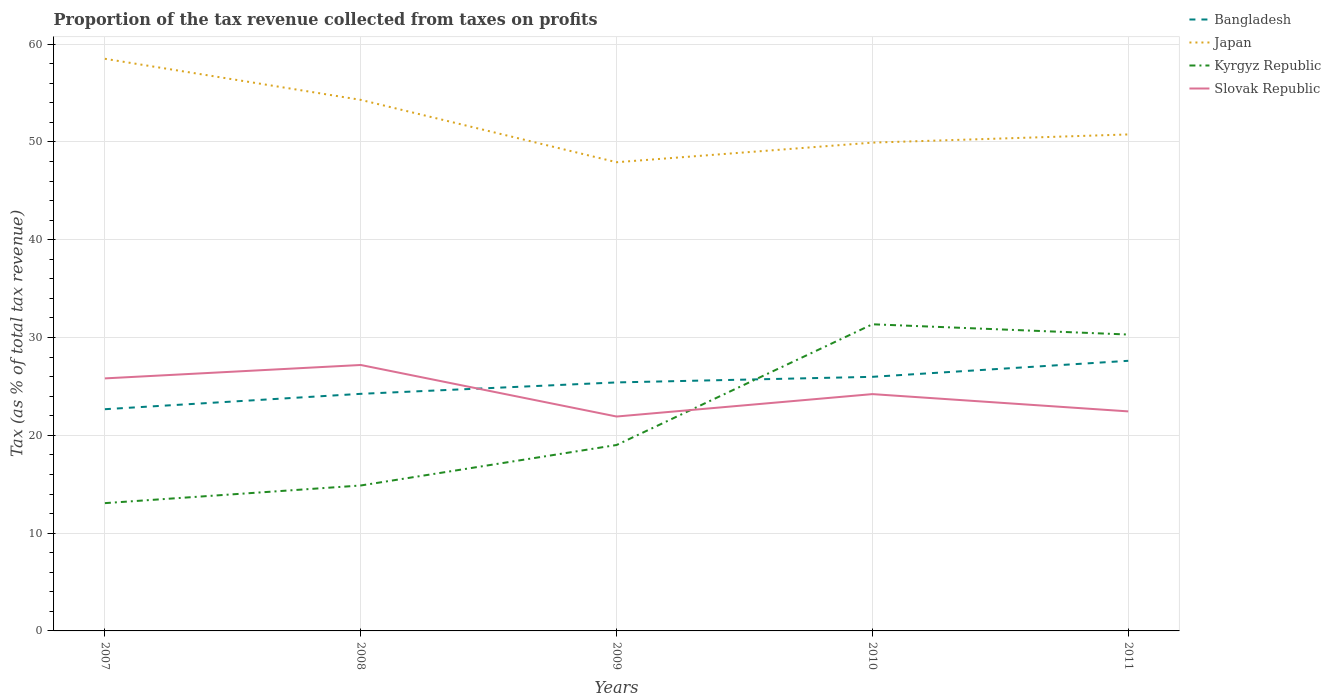Does the line corresponding to Kyrgyz Republic intersect with the line corresponding to Bangladesh?
Provide a short and direct response. Yes. Is the number of lines equal to the number of legend labels?
Give a very brief answer. Yes. Across all years, what is the maximum proportion of the tax revenue collected in Japan?
Your response must be concise. 47.92. What is the total proportion of the tax revenue collected in Slovak Republic in the graph?
Your response must be concise. 2.98. What is the difference between the highest and the second highest proportion of the tax revenue collected in Japan?
Keep it short and to the point. 10.58. What is the difference between the highest and the lowest proportion of the tax revenue collected in Kyrgyz Republic?
Give a very brief answer. 2. How many lines are there?
Your response must be concise. 4. What is the difference between two consecutive major ticks on the Y-axis?
Provide a short and direct response. 10. Does the graph contain any zero values?
Your answer should be very brief. No. How are the legend labels stacked?
Provide a short and direct response. Vertical. What is the title of the graph?
Give a very brief answer. Proportion of the tax revenue collected from taxes on profits. What is the label or title of the X-axis?
Your response must be concise. Years. What is the label or title of the Y-axis?
Ensure brevity in your answer.  Tax (as % of total tax revenue). What is the Tax (as % of total tax revenue) of Bangladesh in 2007?
Your answer should be compact. 22.67. What is the Tax (as % of total tax revenue) in Japan in 2007?
Your answer should be compact. 58.5. What is the Tax (as % of total tax revenue) in Kyrgyz Republic in 2007?
Offer a terse response. 13.07. What is the Tax (as % of total tax revenue) in Slovak Republic in 2007?
Your answer should be very brief. 25.82. What is the Tax (as % of total tax revenue) in Bangladesh in 2008?
Offer a very short reply. 24.24. What is the Tax (as % of total tax revenue) in Japan in 2008?
Your answer should be very brief. 54.3. What is the Tax (as % of total tax revenue) in Kyrgyz Republic in 2008?
Make the answer very short. 14.87. What is the Tax (as % of total tax revenue) of Slovak Republic in 2008?
Your answer should be compact. 27.19. What is the Tax (as % of total tax revenue) of Bangladesh in 2009?
Keep it short and to the point. 25.41. What is the Tax (as % of total tax revenue) of Japan in 2009?
Ensure brevity in your answer.  47.92. What is the Tax (as % of total tax revenue) of Kyrgyz Republic in 2009?
Offer a very short reply. 19.01. What is the Tax (as % of total tax revenue) in Slovak Republic in 2009?
Keep it short and to the point. 21.92. What is the Tax (as % of total tax revenue) in Bangladesh in 2010?
Make the answer very short. 25.98. What is the Tax (as % of total tax revenue) of Japan in 2010?
Provide a short and direct response. 49.93. What is the Tax (as % of total tax revenue) of Kyrgyz Republic in 2010?
Provide a short and direct response. 31.36. What is the Tax (as % of total tax revenue) in Slovak Republic in 2010?
Offer a terse response. 24.21. What is the Tax (as % of total tax revenue) in Bangladesh in 2011?
Provide a succinct answer. 27.62. What is the Tax (as % of total tax revenue) in Japan in 2011?
Provide a short and direct response. 50.77. What is the Tax (as % of total tax revenue) of Kyrgyz Republic in 2011?
Offer a terse response. 30.31. What is the Tax (as % of total tax revenue) in Slovak Republic in 2011?
Give a very brief answer. 22.45. Across all years, what is the maximum Tax (as % of total tax revenue) in Bangladesh?
Keep it short and to the point. 27.62. Across all years, what is the maximum Tax (as % of total tax revenue) in Japan?
Your answer should be compact. 58.5. Across all years, what is the maximum Tax (as % of total tax revenue) in Kyrgyz Republic?
Give a very brief answer. 31.36. Across all years, what is the maximum Tax (as % of total tax revenue) of Slovak Republic?
Make the answer very short. 27.19. Across all years, what is the minimum Tax (as % of total tax revenue) of Bangladesh?
Make the answer very short. 22.67. Across all years, what is the minimum Tax (as % of total tax revenue) of Japan?
Offer a terse response. 47.92. Across all years, what is the minimum Tax (as % of total tax revenue) in Kyrgyz Republic?
Your answer should be compact. 13.07. Across all years, what is the minimum Tax (as % of total tax revenue) of Slovak Republic?
Give a very brief answer. 21.92. What is the total Tax (as % of total tax revenue) in Bangladesh in the graph?
Provide a succinct answer. 125.92. What is the total Tax (as % of total tax revenue) in Japan in the graph?
Your response must be concise. 261.42. What is the total Tax (as % of total tax revenue) in Kyrgyz Republic in the graph?
Ensure brevity in your answer.  108.61. What is the total Tax (as % of total tax revenue) in Slovak Republic in the graph?
Offer a very short reply. 121.6. What is the difference between the Tax (as % of total tax revenue) of Bangladesh in 2007 and that in 2008?
Offer a terse response. -1.57. What is the difference between the Tax (as % of total tax revenue) of Japan in 2007 and that in 2008?
Offer a very short reply. 4.2. What is the difference between the Tax (as % of total tax revenue) in Kyrgyz Republic in 2007 and that in 2008?
Provide a short and direct response. -1.8. What is the difference between the Tax (as % of total tax revenue) in Slovak Republic in 2007 and that in 2008?
Your answer should be compact. -1.37. What is the difference between the Tax (as % of total tax revenue) in Bangladesh in 2007 and that in 2009?
Give a very brief answer. -2.74. What is the difference between the Tax (as % of total tax revenue) in Japan in 2007 and that in 2009?
Ensure brevity in your answer.  10.58. What is the difference between the Tax (as % of total tax revenue) in Kyrgyz Republic in 2007 and that in 2009?
Your answer should be very brief. -5.94. What is the difference between the Tax (as % of total tax revenue) in Slovak Republic in 2007 and that in 2009?
Your answer should be very brief. 3.9. What is the difference between the Tax (as % of total tax revenue) in Bangladesh in 2007 and that in 2010?
Your response must be concise. -3.31. What is the difference between the Tax (as % of total tax revenue) of Japan in 2007 and that in 2010?
Offer a very short reply. 8.57. What is the difference between the Tax (as % of total tax revenue) in Kyrgyz Republic in 2007 and that in 2010?
Your answer should be very brief. -18.29. What is the difference between the Tax (as % of total tax revenue) of Slovak Republic in 2007 and that in 2010?
Offer a very short reply. 1.61. What is the difference between the Tax (as % of total tax revenue) of Bangladesh in 2007 and that in 2011?
Provide a short and direct response. -4.95. What is the difference between the Tax (as % of total tax revenue) of Japan in 2007 and that in 2011?
Your answer should be very brief. 7.74. What is the difference between the Tax (as % of total tax revenue) of Kyrgyz Republic in 2007 and that in 2011?
Ensure brevity in your answer.  -17.24. What is the difference between the Tax (as % of total tax revenue) in Slovak Republic in 2007 and that in 2011?
Give a very brief answer. 3.37. What is the difference between the Tax (as % of total tax revenue) in Bangladesh in 2008 and that in 2009?
Provide a succinct answer. -1.17. What is the difference between the Tax (as % of total tax revenue) of Japan in 2008 and that in 2009?
Ensure brevity in your answer.  6.38. What is the difference between the Tax (as % of total tax revenue) of Kyrgyz Republic in 2008 and that in 2009?
Your answer should be very brief. -4.14. What is the difference between the Tax (as % of total tax revenue) in Slovak Republic in 2008 and that in 2009?
Ensure brevity in your answer.  5.27. What is the difference between the Tax (as % of total tax revenue) of Bangladesh in 2008 and that in 2010?
Provide a short and direct response. -1.74. What is the difference between the Tax (as % of total tax revenue) in Japan in 2008 and that in 2010?
Make the answer very short. 4.37. What is the difference between the Tax (as % of total tax revenue) in Kyrgyz Republic in 2008 and that in 2010?
Ensure brevity in your answer.  -16.48. What is the difference between the Tax (as % of total tax revenue) of Slovak Republic in 2008 and that in 2010?
Provide a short and direct response. 2.98. What is the difference between the Tax (as % of total tax revenue) of Bangladesh in 2008 and that in 2011?
Provide a succinct answer. -3.38. What is the difference between the Tax (as % of total tax revenue) of Japan in 2008 and that in 2011?
Offer a terse response. 3.54. What is the difference between the Tax (as % of total tax revenue) in Kyrgyz Republic in 2008 and that in 2011?
Offer a very short reply. -15.44. What is the difference between the Tax (as % of total tax revenue) of Slovak Republic in 2008 and that in 2011?
Keep it short and to the point. 4.74. What is the difference between the Tax (as % of total tax revenue) of Bangladesh in 2009 and that in 2010?
Your response must be concise. -0.57. What is the difference between the Tax (as % of total tax revenue) of Japan in 2009 and that in 2010?
Ensure brevity in your answer.  -2. What is the difference between the Tax (as % of total tax revenue) of Kyrgyz Republic in 2009 and that in 2010?
Your answer should be compact. -12.34. What is the difference between the Tax (as % of total tax revenue) of Slovak Republic in 2009 and that in 2010?
Your response must be concise. -2.29. What is the difference between the Tax (as % of total tax revenue) in Bangladesh in 2009 and that in 2011?
Offer a terse response. -2.21. What is the difference between the Tax (as % of total tax revenue) of Japan in 2009 and that in 2011?
Your answer should be compact. -2.84. What is the difference between the Tax (as % of total tax revenue) in Kyrgyz Republic in 2009 and that in 2011?
Your answer should be compact. -11.3. What is the difference between the Tax (as % of total tax revenue) of Slovak Republic in 2009 and that in 2011?
Your answer should be very brief. -0.53. What is the difference between the Tax (as % of total tax revenue) of Bangladesh in 2010 and that in 2011?
Keep it short and to the point. -1.64. What is the difference between the Tax (as % of total tax revenue) in Japan in 2010 and that in 2011?
Offer a very short reply. -0.84. What is the difference between the Tax (as % of total tax revenue) of Kyrgyz Republic in 2010 and that in 2011?
Give a very brief answer. 1.05. What is the difference between the Tax (as % of total tax revenue) of Slovak Republic in 2010 and that in 2011?
Your response must be concise. 1.77. What is the difference between the Tax (as % of total tax revenue) of Bangladesh in 2007 and the Tax (as % of total tax revenue) of Japan in 2008?
Your answer should be very brief. -31.63. What is the difference between the Tax (as % of total tax revenue) in Bangladesh in 2007 and the Tax (as % of total tax revenue) in Kyrgyz Republic in 2008?
Offer a very short reply. 7.8. What is the difference between the Tax (as % of total tax revenue) in Bangladesh in 2007 and the Tax (as % of total tax revenue) in Slovak Republic in 2008?
Ensure brevity in your answer.  -4.52. What is the difference between the Tax (as % of total tax revenue) in Japan in 2007 and the Tax (as % of total tax revenue) in Kyrgyz Republic in 2008?
Offer a very short reply. 43.63. What is the difference between the Tax (as % of total tax revenue) in Japan in 2007 and the Tax (as % of total tax revenue) in Slovak Republic in 2008?
Offer a very short reply. 31.31. What is the difference between the Tax (as % of total tax revenue) in Kyrgyz Republic in 2007 and the Tax (as % of total tax revenue) in Slovak Republic in 2008?
Your answer should be very brief. -14.13. What is the difference between the Tax (as % of total tax revenue) in Bangladesh in 2007 and the Tax (as % of total tax revenue) in Japan in 2009?
Your answer should be compact. -25.25. What is the difference between the Tax (as % of total tax revenue) in Bangladesh in 2007 and the Tax (as % of total tax revenue) in Kyrgyz Republic in 2009?
Your answer should be very brief. 3.66. What is the difference between the Tax (as % of total tax revenue) of Bangladesh in 2007 and the Tax (as % of total tax revenue) of Slovak Republic in 2009?
Your answer should be compact. 0.75. What is the difference between the Tax (as % of total tax revenue) in Japan in 2007 and the Tax (as % of total tax revenue) in Kyrgyz Republic in 2009?
Give a very brief answer. 39.49. What is the difference between the Tax (as % of total tax revenue) in Japan in 2007 and the Tax (as % of total tax revenue) in Slovak Republic in 2009?
Make the answer very short. 36.58. What is the difference between the Tax (as % of total tax revenue) in Kyrgyz Republic in 2007 and the Tax (as % of total tax revenue) in Slovak Republic in 2009?
Offer a very short reply. -8.86. What is the difference between the Tax (as % of total tax revenue) of Bangladesh in 2007 and the Tax (as % of total tax revenue) of Japan in 2010?
Offer a terse response. -27.26. What is the difference between the Tax (as % of total tax revenue) of Bangladesh in 2007 and the Tax (as % of total tax revenue) of Kyrgyz Republic in 2010?
Offer a terse response. -8.68. What is the difference between the Tax (as % of total tax revenue) in Bangladesh in 2007 and the Tax (as % of total tax revenue) in Slovak Republic in 2010?
Give a very brief answer. -1.54. What is the difference between the Tax (as % of total tax revenue) in Japan in 2007 and the Tax (as % of total tax revenue) in Kyrgyz Republic in 2010?
Ensure brevity in your answer.  27.15. What is the difference between the Tax (as % of total tax revenue) of Japan in 2007 and the Tax (as % of total tax revenue) of Slovak Republic in 2010?
Keep it short and to the point. 34.29. What is the difference between the Tax (as % of total tax revenue) in Kyrgyz Republic in 2007 and the Tax (as % of total tax revenue) in Slovak Republic in 2010?
Keep it short and to the point. -11.15. What is the difference between the Tax (as % of total tax revenue) of Bangladesh in 2007 and the Tax (as % of total tax revenue) of Japan in 2011?
Provide a short and direct response. -28.1. What is the difference between the Tax (as % of total tax revenue) in Bangladesh in 2007 and the Tax (as % of total tax revenue) in Kyrgyz Republic in 2011?
Give a very brief answer. -7.64. What is the difference between the Tax (as % of total tax revenue) of Bangladesh in 2007 and the Tax (as % of total tax revenue) of Slovak Republic in 2011?
Provide a succinct answer. 0.22. What is the difference between the Tax (as % of total tax revenue) of Japan in 2007 and the Tax (as % of total tax revenue) of Kyrgyz Republic in 2011?
Give a very brief answer. 28.2. What is the difference between the Tax (as % of total tax revenue) of Japan in 2007 and the Tax (as % of total tax revenue) of Slovak Republic in 2011?
Provide a short and direct response. 36.05. What is the difference between the Tax (as % of total tax revenue) in Kyrgyz Republic in 2007 and the Tax (as % of total tax revenue) in Slovak Republic in 2011?
Keep it short and to the point. -9.38. What is the difference between the Tax (as % of total tax revenue) of Bangladesh in 2008 and the Tax (as % of total tax revenue) of Japan in 2009?
Provide a succinct answer. -23.68. What is the difference between the Tax (as % of total tax revenue) of Bangladesh in 2008 and the Tax (as % of total tax revenue) of Kyrgyz Republic in 2009?
Offer a very short reply. 5.23. What is the difference between the Tax (as % of total tax revenue) of Bangladesh in 2008 and the Tax (as % of total tax revenue) of Slovak Republic in 2009?
Keep it short and to the point. 2.32. What is the difference between the Tax (as % of total tax revenue) of Japan in 2008 and the Tax (as % of total tax revenue) of Kyrgyz Republic in 2009?
Your response must be concise. 35.29. What is the difference between the Tax (as % of total tax revenue) of Japan in 2008 and the Tax (as % of total tax revenue) of Slovak Republic in 2009?
Offer a very short reply. 32.38. What is the difference between the Tax (as % of total tax revenue) in Kyrgyz Republic in 2008 and the Tax (as % of total tax revenue) in Slovak Republic in 2009?
Your answer should be very brief. -7.05. What is the difference between the Tax (as % of total tax revenue) of Bangladesh in 2008 and the Tax (as % of total tax revenue) of Japan in 2010?
Provide a short and direct response. -25.69. What is the difference between the Tax (as % of total tax revenue) of Bangladesh in 2008 and the Tax (as % of total tax revenue) of Kyrgyz Republic in 2010?
Make the answer very short. -7.11. What is the difference between the Tax (as % of total tax revenue) of Bangladesh in 2008 and the Tax (as % of total tax revenue) of Slovak Republic in 2010?
Your answer should be very brief. 0.03. What is the difference between the Tax (as % of total tax revenue) of Japan in 2008 and the Tax (as % of total tax revenue) of Kyrgyz Republic in 2010?
Offer a terse response. 22.95. What is the difference between the Tax (as % of total tax revenue) of Japan in 2008 and the Tax (as % of total tax revenue) of Slovak Republic in 2010?
Ensure brevity in your answer.  30.09. What is the difference between the Tax (as % of total tax revenue) of Kyrgyz Republic in 2008 and the Tax (as % of total tax revenue) of Slovak Republic in 2010?
Your response must be concise. -9.34. What is the difference between the Tax (as % of total tax revenue) in Bangladesh in 2008 and the Tax (as % of total tax revenue) in Japan in 2011?
Ensure brevity in your answer.  -26.52. What is the difference between the Tax (as % of total tax revenue) of Bangladesh in 2008 and the Tax (as % of total tax revenue) of Kyrgyz Republic in 2011?
Your answer should be very brief. -6.06. What is the difference between the Tax (as % of total tax revenue) of Bangladesh in 2008 and the Tax (as % of total tax revenue) of Slovak Republic in 2011?
Provide a short and direct response. 1.79. What is the difference between the Tax (as % of total tax revenue) of Japan in 2008 and the Tax (as % of total tax revenue) of Kyrgyz Republic in 2011?
Offer a terse response. 24. What is the difference between the Tax (as % of total tax revenue) of Japan in 2008 and the Tax (as % of total tax revenue) of Slovak Republic in 2011?
Offer a terse response. 31.85. What is the difference between the Tax (as % of total tax revenue) of Kyrgyz Republic in 2008 and the Tax (as % of total tax revenue) of Slovak Republic in 2011?
Offer a terse response. -7.58. What is the difference between the Tax (as % of total tax revenue) in Bangladesh in 2009 and the Tax (as % of total tax revenue) in Japan in 2010?
Offer a terse response. -24.52. What is the difference between the Tax (as % of total tax revenue) in Bangladesh in 2009 and the Tax (as % of total tax revenue) in Kyrgyz Republic in 2010?
Make the answer very short. -5.95. What is the difference between the Tax (as % of total tax revenue) of Bangladesh in 2009 and the Tax (as % of total tax revenue) of Slovak Republic in 2010?
Provide a succinct answer. 1.2. What is the difference between the Tax (as % of total tax revenue) in Japan in 2009 and the Tax (as % of total tax revenue) in Kyrgyz Republic in 2010?
Offer a very short reply. 16.57. What is the difference between the Tax (as % of total tax revenue) in Japan in 2009 and the Tax (as % of total tax revenue) in Slovak Republic in 2010?
Make the answer very short. 23.71. What is the difference between the Tax (as % of total tax revenue) of Kyrgyz Republic in 2009 and the Tax (as % of total tax revenue) of Slovak Republic in 2010?
Provide a succinct answer. -5.2. What is the difference between the Tax (as % of total tax revenue) of Bangladesh in 2009 and the Tax (as % of total tax revenue) of Japan in 2011?
Your response must be concise. -25.36. What is the difference between the Tax (as % of total tax revenue) of Bangladesh in 2009 and the Tax (as % of total tax revenue) of Kyrgyz Republic in 2011?
Give a very brief answer. -4.9. What is the difference between the Tax (as % of total tax revenue) in Bangladesh in 2009 and the Tax (as % of total tax revenue) in Slovak Republic in 2011?
Your answer should be very brief. 2.96. What is the difference between the Tax (as % of total tax revenue) in Japan in 2009 and the Tax (as % of total tax revenue) in Kyrgyz Republic in 2011?
Provide a short and direct response. 17.62. What is the difference between the Tax (as % of total tax revenue) in Japan in 2009 and the Tax (as % of total tax revenue) in Slovak Republic in 2011?
Your response must be concise. 25.48. What is the difference between the Tax (as % of total tax revenue) of Kyrgyz Republic in 2009 and the Tax (as % of total tax revenue) of Slovak Republic in 2011?
Make the answer very short. -3.44. What is the difference between the Tax (as % of total tax revenue) of Bangladesh in 2010 and the Tax (as % of total tax revenue) of Japan in 2011?
Give a very brief answer. -24.78. What is the difference between the Tax (as % of total tax revenue) of Bangladesh in 2010 and the Tax (as % of total tax revenue) of Kyrgyz Republic in 2011?
Make the answer very short. -4.32. What is the difference between the Tax (as % of total tax revenue) of Bangladesh in 2010 and the Tax (as % of total tax revenue) of Slovak Republic in 2011?
Provide a short and direct response. 3.53. What is the difference between the Tax (as % of total tax revenue) in Japan in 2010 and the Tax (as % of total tax revenue) in Kyrgyz Republic in 2011?
Your response must be concise. 19.62. What is the difference between the Tax (as % of total tax revenue) in Japan in 2010 and the Tax (as % of total tax revenue) in Slovak Republic in 2011?
Offer a terse response. 27.48. What is the difference between the Tax (as % of total tax revenue) of Kyrgyz Republic in 2010 and the Tax (as % of total tax revenue) of Slovak Republic in 2011?
Keep it short and to the point. 8.91. What is the average Tax (as % of total tax revenue) in Bangladesh per year?
Your response must be concise. 25.18. What is the average Tax (as % of total tax revenue) in Japan per year?
Your answer should be very brief. 52.28. What is the average Tax (as % of total tax revenue) in Kyrgyz Republic per year?
Your response must be concise. 21.72. What is the average Tax (as % of total tax revenue) in Slovak Republic per year?
Ensure brevity in your answer.  24.32. In the year 2007, what is the difference between the Tax (as % of total tax revenue) of Bangladesh and Tax (as % of total tax revenue) of Japan?
Ensure brevity in your answer.  -35.83. In the year 2007, what is the difference between the Tax (as % of total tax revenue) of Bangladesh and Tax (as % of total tax revenue) of Kyrgyz Republic?
Your answer should be compact. 9.6. In the year 2007, what is the difference between the Tax (as % of total tax revenue) of Bangladesh and Tax (as % of total tax revenue) of Slovak Republic?
Keep it short and to the point. -3.15. In the year 2007, what is the difference between the Tax (as % of total tax revenue) in Japan and Tax (as % of total tax revenue) in Kyrgyz Republic?
Offer a very short reply. 45.43. In the year 2007, what is the difference between the Tax (as % of total tax revenue) in Japan and Tax (as % of total tax revenue) in Slovak Republic?
Ensure brevity in your answer.  32.68. In the year 2007, what is the difference between the Tax (as % of total tax revenue) of Kyrgyz Republic and Tax (as % of total tax revenue) of Slovak Republic?
Your answer should be very brief. -12.75. In the year 2008, what is the difference between the Tax (as % of total tax revenue) of Bangladesh and Tax (as % of total tax revenue) of Japan?
Your answer should be very brief. -30.06. In the year 2008, what is the difference between the Tax (as % of total tax revenue) in Bangladesh and Tax (as % of total tax revenue) in Kyrgyz Republic?
Give a very brief answer. 9.37. In the year 2008, what is the difference between the Tax (as % of total tax revenue) in Bangladesh and Tax (as % of total tax revenue) in Slovak Republic?
Ensure brevity in your answer.  -2.95. In the year 2008, what is the difference between the Tax (as % of total tax revenue) in Japan and Tax (as % of total tax revenue) in Kyrgyz Republic?
Provide a short and direct response. 39.43. In the year 2008, what is the difference between the Tax (as % of total tax revenue) of Japan and Tax (as % of total tax revenue) of Slovak Republic?
Ensure brevity in your answer.  27.11. In the year 2008, what is the difference between the Tax (as % of total tax revenue) of Kyrgyz Republic and Tax (as % of total tax revenue) of Slovak Republic?
Give a very brief answer. -12.32. In the year 2009, what is the difference between the Tax (as % of total tax revenue) of Bangladesh and Tax (as % of total tax revenue) of Japan?
Your answer should be very brief. -22.52. In the year 2009, what is the difference between the Tax (as % of total tax revenue) of Bangladesh and Tax (as % of total tax revenue) of Kyrgyz Republic?
Provide a succinct answer. 6.4. In the year 2009, what is the difference between the Tax (as % of total tax revenue) of Bangladesh and Tax (as % of total tax revenue) of Slovak Republic?
Provide a short and direct response. 3.49. In the year 2009, what is the difference between the Tax (as % of total tax revenue) in Japan and Tax (as % of total tax revenue) in Kyrgyz Republic?
Offer a terse response. 28.91. In the year 2009, what is the difference between the Tax (as % of total tax revenue) in Japan and Tax (as % of total tax revenue) in Slovak Republic?
Your answer should be very brief. 26. In the year 2009, what is the difference between the Tax (as % of total tax revenue) in Kyrgyz Republic and Tax (as % of total tax revenue) in Slovak Republic?
Provide a short and direct response. -2.91. In the year 2010, what is the difference between the Tax (as % of total tax revenue) in Bangladesh and Tax (as % of total tax revenue) in Japan?
Provide a short and direct response. -23.95. In the year 2010, what is the difference between the Tax (as % of total tax revenue) of Bangladesh and Tax (as % of total tax revenue) of Kyrgyz Republic?
Your response must be concise. -5.37. In the year 2010, what is the difference between the Tax (as % of total tax revenue) of Bangladesh and Tax (as % of total tax revenue) of Slovak Republic?
Give a very brief answer. 1.77. In the year 2010, what is the difference between the Tax (as % of total tax revenue) of Japan and Tax (as % of total tax revenue) of Kyrgyz Republic?
Make the answer very short. 18.57. In the year 2010, what is the difference between the Tax (as % of total tax revenue) of Japan and Tax (as % of total tax revenue) of Slovak Republic?
Give a very brief answer. 25.72. In the year 2010, what is the difference between the Tax (as % of total tax revenue) in Kyrgyz Republic and Tax (as % of total tax revenue) in Slovak Republic?
Ensure brevity in your answer.  7.14. In the year 2011, what is the difference between the Tax (as % of total tax revenue) of Bangladesh and Tax (as % of total tax revenue) of Japan?
Offer a terse response. -23.15. In the year 2011, what is the difference between the Tax (as % of total tax revenue) of Bangladesh and Tax (as % of total tax revenue) of Kyrgyz Republic?
Provide a succinct answer. -2.69. In the year 2011, what is the difference between the Tax (as % of total tax revenue) in Bangladesh and Tax (as % of total tax revenue) in Slovak Republic?
Give a very brief answer. 5.17. In the year 2011, what is the difference between the Tax (as % of total tax revenue) of Japan and Tax (as % of total tax revenue) of Kyrgyz Republic?
Your answer should be very brief. 20.46. In the year 2011, what is the difference between the Tax (as % of total tax revenue) of Japan and Tax (as % of total tax revenue) of Slovak Republic?
Give a very brief answer. 28.32. In the year 2011, what is the difference between the Tax (as % of total tax revenue) in Kyrgyz Republic and Tax (as % of total tax revenue) in Slovak Republic?
Provide a short and direct response. 7.86. What is the ratio of the Tax (as % of total tax revenue) of Bangladesh in 2007 to that in 2008?
Give a very brief answer. 0.94. What is the ratio of the Tax (as % of total tax revenue) in Japan in 2007 to that in 2008?
Provide a short and direct response. 1.08. What is the ratio of the Tax (as % of total tax revenue) of Kyrgyz Republic in 2007 to that in 2008?
Make the answer very short. 0.88. What is the ratio of the Tax (as % of total tax revenue) of Slovak Republic in 2007 to that in 2008?
Offer a terse response. 0.95. What is the ratio of the Tax (as % of total tax revenue) of Bangladesh in 2007 to that in 2009?
Your response must be concise. 0.89. What is the ratio of the Tax (as % of total tax revenue) of Japan in 2007 to that in 2009?
Offer a very short reply. 1.22. What is the ratio of the Tax (as % of total tax revenue) of Kyrgyz Republic in 2007 to that in 2009?
Offer a very short reply. 0.69. What is the ratio of the Tax (as % of total tax revenue) in Slovak Republic in 2007 to that in 2009?
Give a very brief answer. 1.18. What is the ratio of the Tax (as % of total tax revenue) in Bangladesh in 2007 to that in 2010?
Your answer should be very brief. 0.87. What is the ratio of the Tax (as % of total tax revenue) of Japan in 2007 to that in 2010?
Offer a very short reply. 1.17. What is the ratio of the Tax (as % of total tax revenue) of Kyrgyz Republic in 2007 to that in 2010?
Provide a succinct answer. 0.42. What is the ratio of the Tax (as % of total tax revenue) in Slovak Republic in 2007 to that in 2010?
Make the answer very short. 1.07. What is the ratio of the Tax (as % of total tax revenue) of Bangladesh in 2007 to that in 2011?
Make the answer very short. 0.82. What is the ratio of the Tax (as % of total tax revenue) in Japan in 2007 to that in 2011?
Provide a short and direct response. 1.15. What is the ratio of the Tax (as % of total tax revenue) in Kyrgyz Republic in 2007 to that in 2011?
Give a very brief answer. 0.43. What is the ratio of the Tax (as % of total tax revenue) in Slovak Republic in 2007 to that in 2011?
Offer a terse response. 1.15. What is the ratio of the Tax (as % of total tax revenue) of Bangladesh in 2008 to that in 2009?
Provide a succinct answer. 0.95. What is the ratio of the Tax (as % of total tax revenue) of Japan in 2008 to that in 2009?
Ensure brevity in your answer.  1.13. What is the ratio of the Tax (as % of total tax revenue) of Kyrgyz Republic in 2008 to that in 2009?
Your response must be concise. 0.78. What is the ratio of the Tax (as % of total tax revenue) in Slovak Republic in 2008 to that in 2009?
Provide a short and direct response. 1.24. What is the ratio of the Tax (as % of total tax revenue) in Bangladesh in 2008 to that in 2010?
Keep it short and to the point. 0.93. What is the ratio of the Tax (as % of total tax revenue) in Japan in 2008 to that in 2010?
Your response must be concise. 1.09. What is the ratio of the Tax (as % of total tax revenue) of Kyrgyz Republic in 2008 to that in 2010?
Offer a terse response. 0.47. What is the ratio of the Tax (as % of total tax revenue) in Slovak Republic in 2008 to that in 2010?
Your response must be concise. 1.12. What is the ratio of the Tax (as % of total tax revenue) in Bangladesh in 2008 to that in 2011?
Make the answer very short. 0.88. What is the ratio of the Tax (as % of total tax revenue) of Japan in 2008 to that in 2011?
Ensure brevity in your answer.  1.07. What is the ratio of the Tax (as % of total tax revenue) of Kyrgyz Republic in 2008 to that in 2011?
Your response must be concise. 0.49. What is the ratio of the Tax (as % of total tax revenue) of Slovak Republic in 2008 to that in 2011?
Give a very brief answer. 1.21. What is the ratio of the Tax (as % of total tax revenue) of Japan in 2009 to that in 2010?
Provide a short and direct response. 0.96. What is the ratio of the Tax (as % of total tax revenue) of Kyrgyz Republic in 2009 to that in 2010?
Your answer should be very brief. 0.61. What is the ratio of the Tax (as % of total tax revenue) in Slovak Republic in 2009 to that in 2010?
Ensure brevity in your answer.  0.91. What is the ratio of the Tax (as % of total tax revenue) of Japan in 2009 to that in 2011?
Provide a succinct answer. 0.94. What is the ratio of the Tax (as % of total tax revenue) in Kyrgyz Republic in 2009 to that in 2011?
Offer a terse response. 0.63. What is the ratio of the Tax (as % of total tax revenue) of Slovak Republic in 2009 to that in 2011?
Your answer should be very brief. 0.98. What is the ratio of the Tax (as % of total tax revenue) in Bangladesh in 2010 to that in 2011?
Offer a terse response. 0.94. What is the ratio of the Tax (as % of total tax revenue) of Japan in 2010 to that in 2011?
Give a very brief answer. 0.98. What is the ratio of the Tax (as % of total tax revenue) of Kyrgyz Republic in 2010 to that in 2011?
Your response must be concise. 1.03. What is the ratio of the Tax (as % of total tax revenue) of Slovak Republic in 2010 to that in 2011?
Provide a succinct answer. 1.08. What is the difference between the highest and the second highest Tax (as % of total tax revenue) in Bangladesh?
Ensure brevity in your answer.  1.64. What is the difference between the highest and the second highest Tax (as % of total tax revenue) in Japan?
Your answer should be compact. 4.2. What is the difference between the highest and the second highest Tax (as % of total tax revenue) in Kyrgyz Republic?
Provide a succinct answer. 1.05. What is the difference between the highest and the second highest Tax (as % of total tax revenue) in Slovak Republic?
Keep it short and to the point. 1.37. What is the difference between the highest and the lowest Tax (as % of total tax revenue) of Bangladesh?
Give a very brief answer. 4.95. What is the difference between the highest and the lowest Tax (as % of total tax revenue) of Japan?
Offer a terse response. 10.58. What is the difference between the highest and the lowest Tax (as % of total tax revenue) of Kyrgyz Republic?
Make the answer very short. 18.29. What is the difference between the highest and the lowest Tax (as % of total tax revenue) in Slovak Republic?
Ensure brevity in your answer.  5.27. 